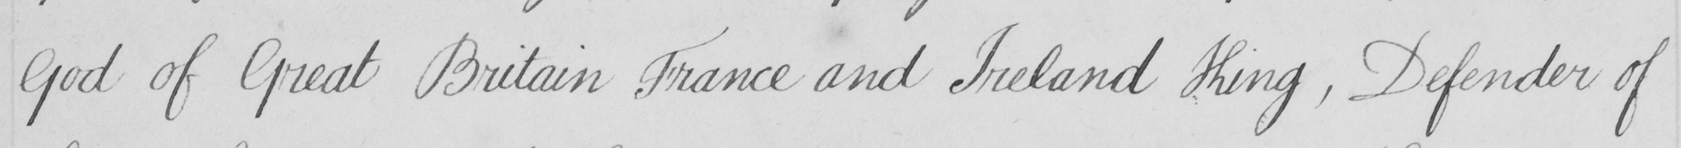Please provide the text content of this handwritten line. God of Great Britain France and Ireland King , Defender of 